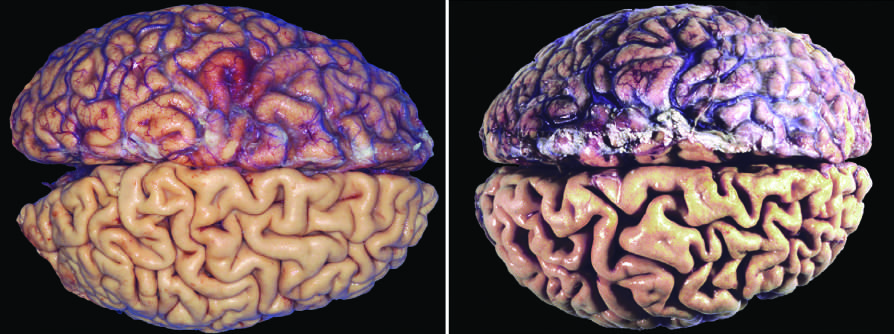what is caused by aging and reduced blood supply?
Answer the question using a single word or phrase. Atrophy of the brain 